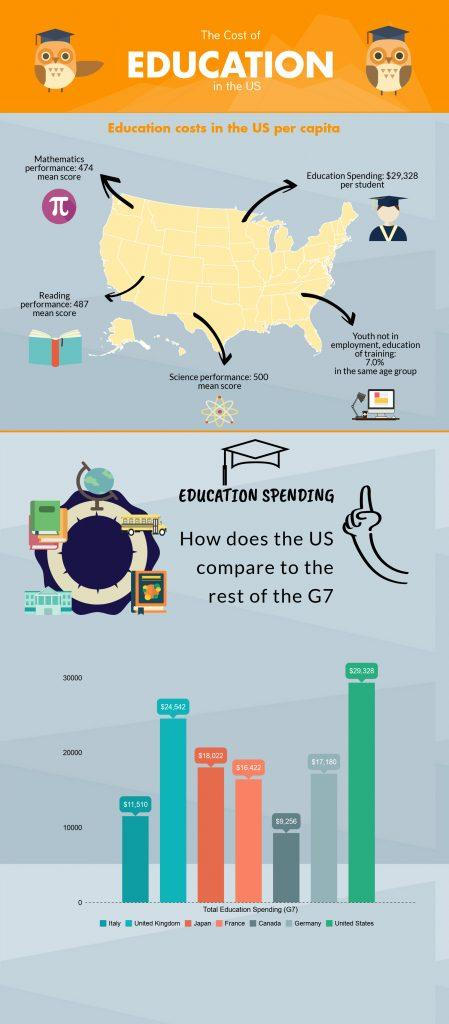Indicate a few pertinent items in this graphic. The difference in total education spending between the United States and the United Kingdom is $4,816. The difference between the highest and lowest amount spent on education in the United States is $21,072. The total education spending by all G7 countries is $125,230. It is reported that Japan spends the highest amount of money on education among the countries of France, Japan, and Canada. 